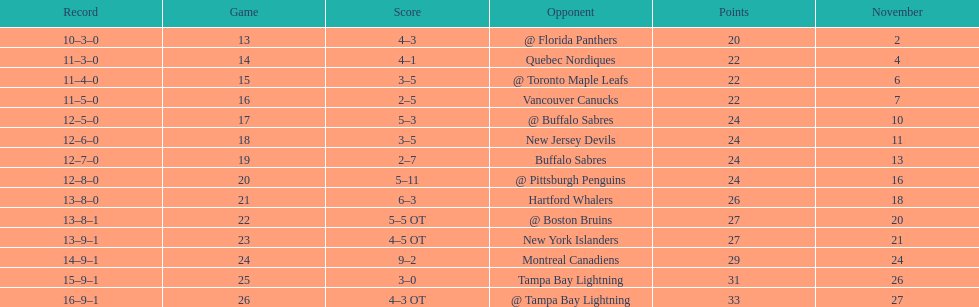Parse the full table. {'header': ['Record', 'Game', 'Score', 'Opponent', 'Points', 'November'], 'rows': [['10–3–0', '13', '4–3', '@ Florida Panthers', '20', '2'], ['11–3–0', '14', '4–1', 'Quebec Nordiques', '22', '4'], ['11–4–0', '15', '3–5', '@ Toronto Maple Leafs', '22', '6'], ['11–5–0', '16', '2–5', 'Vancouver Canucks', '22', '7'], ['12–5–0', '17', '5–3', '@ Buffalo Sabres', '24', '10'], ['12–6–0', '18', '3–5', 'New Jersey Devils', '24', '11'], ['12–7–0', '19', '2–7', 'Buffalo Sabres', '24', '13'], ['12–8–0', '20', '5–11', '@ Pittsburgh Penguins', '24', '16'], ['13–8–0', '21', '6–3', 'Hartford Whalers', '26', '18'], ['13–8–1', '22', '5–5 OT', '@ Boston Bruins', '27', '20'], ['13–9–1', '23', '4–5 OT', 'New York Islanders', '27', '21'], ['14–9–1', '24', '9–2', 'Montreal Canadiens', '29', '24'], ['15–9–1', '25', '3–0', 'Tampa Bay Lightning', '31', '26'], ['16–9–1', '26', '4–3 OT', '@ Tampa Bay Lightning', '33', '27']]} What was the number of wins the philadelphia flyers had? 35. 